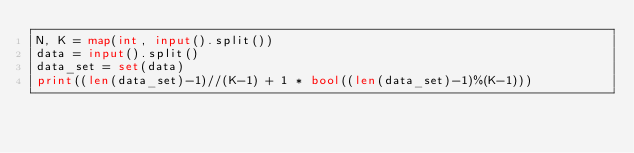<code> <loc_0><loc_0><loc_500><loc_500><_Python_>N, K = map(int, input().split())
data = input().split()
data_set = set(data)
print((len(data_set)-1)//(K-1) + 1 * bool((len(data_set)-1)%(K-1)))</code> 